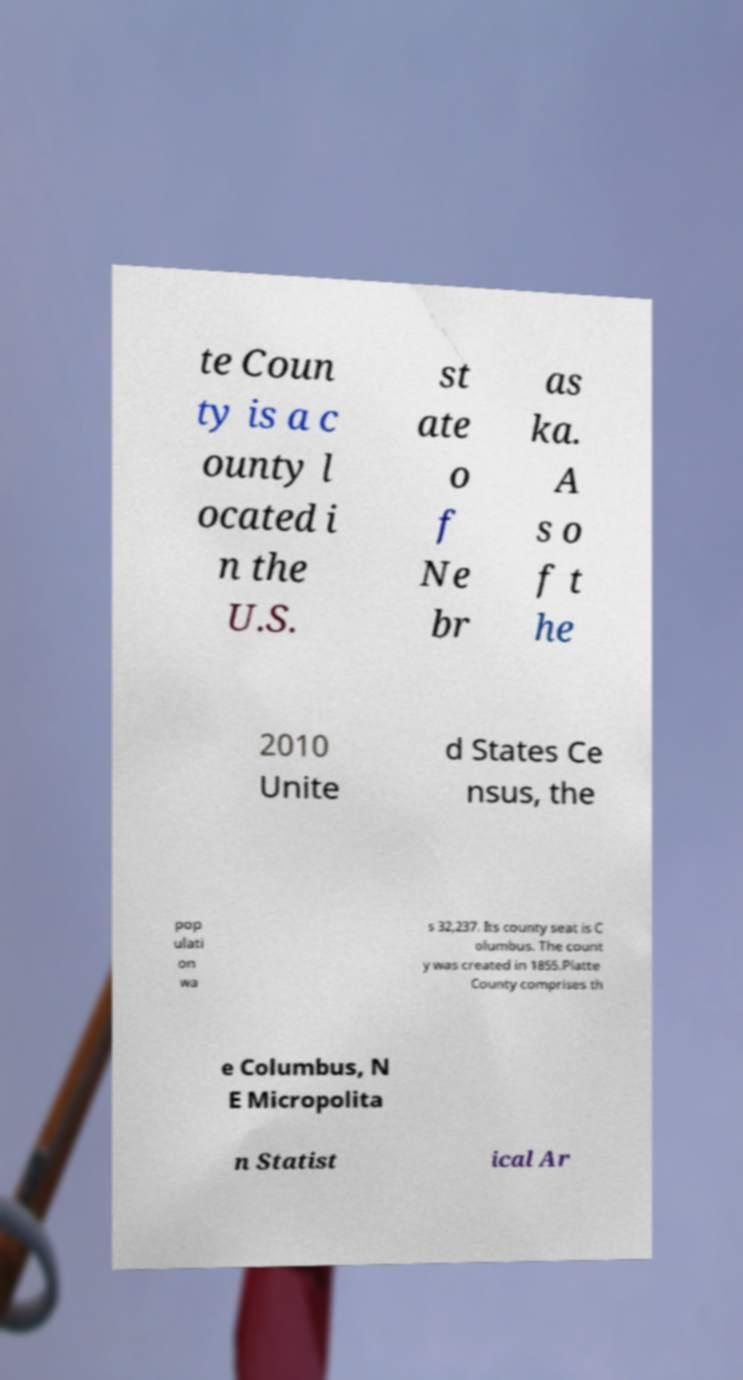Could you extract and type out the text from this image? te Coun ty is a c ounty l ocated i n the U.S. st ate o f Ne br as ka. A s o f t he 2010 Unite d States Ce nsus, the pop ulati on wa s 32,237. Its county seat is C olumbus. The count y was created in 1855.Platte County comprises th e Columbus, N E Micropolita n Statist ical Ar 